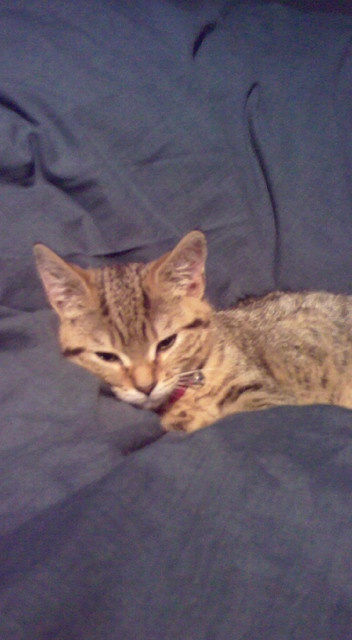Describe the objects in this image and their specific colors. I can see bed in gray, purple, navy, and darkblue tones and cat in purple, gray, and tan tones in this image. 